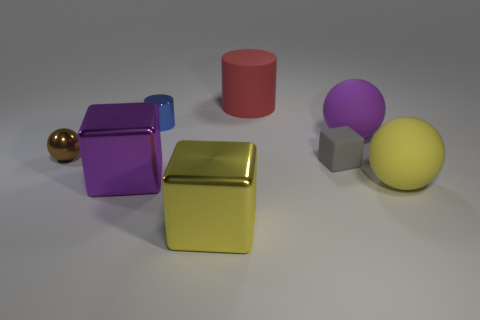Is the size of the yellow rubber object the same as the brown metallic sphere?
Offer a very short reply. No. The large yellow object that is made of the same material as the blue thing is what shape?
Offer a terse response. Cube. What number of other objects are there of the same shape as the blue metal thing?
Your response must be concise. 1. There is a yellow thing right of the big rubber thing behind the big matte ball behind the gray rubber thing; what shape is it?
Your answer should be compact. Sphere. How many blocks are large objects or small gray matte objects?
Your answer should be compact. 3. There is a metallic cube left of the yellow metallic cube; is there a large yellow ball in front of it?
Offer a very short reply. Yes. Are there any other things that are the same material as the yellow sphere?
Your response must be concise. Yes. There is a big purple matte thing; is its shape the same as the big yellow object that is to the right of the yellow metal cube?
Give a very brief answer. Yes. How many other things are there of the same size as the yellow shiny object?
Make the answer very short. 4. How many red things are either metal spheres or matte cylinders?
Keep it short and to the point. 1. 